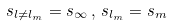Convert formula to latex. <formula><loc_0><loc_0><loc_500><loc_500>s _ { { l } \neq { l } _ { m } } = s _ { \infty } \, , \, s _ { { l } _ { m } } = s _ { m }</formula> 